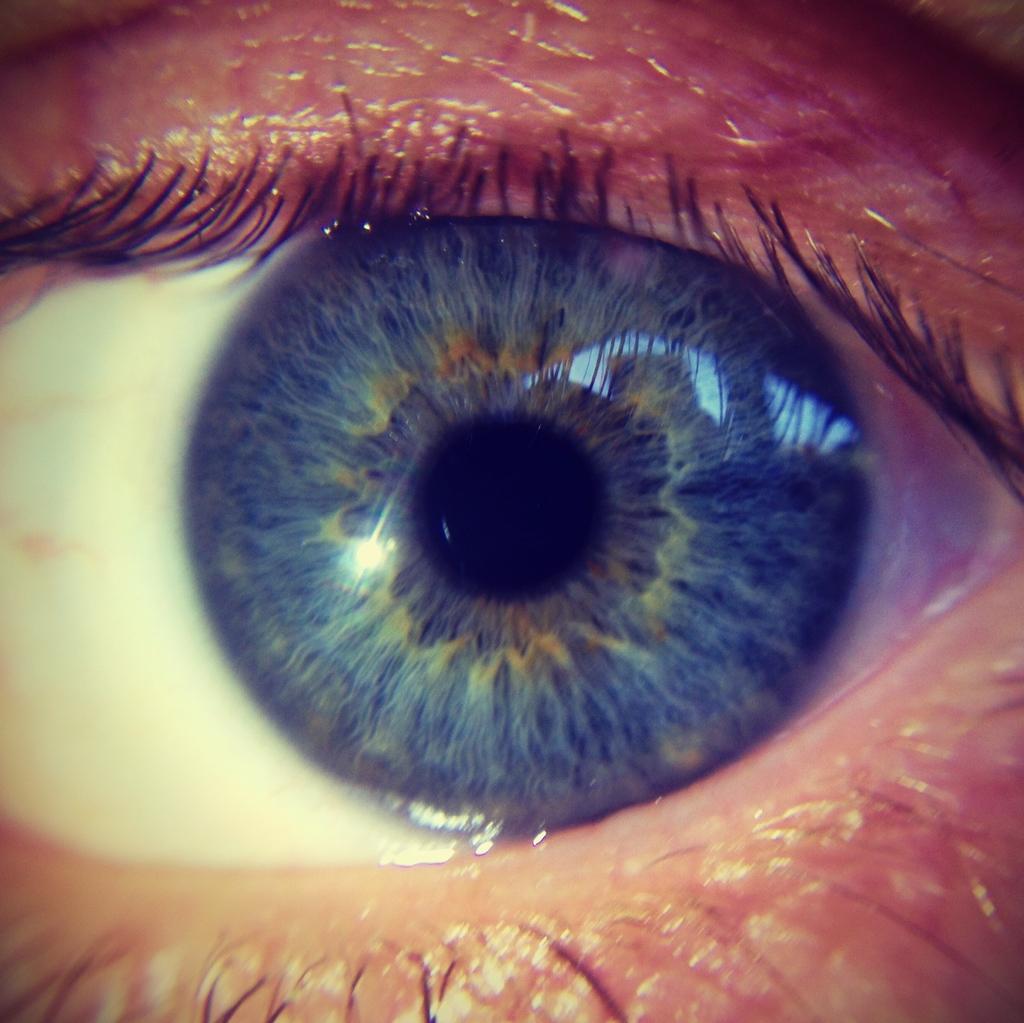Could you give a brief overview of what you see in this image? In this image we can see the eye of a person. 